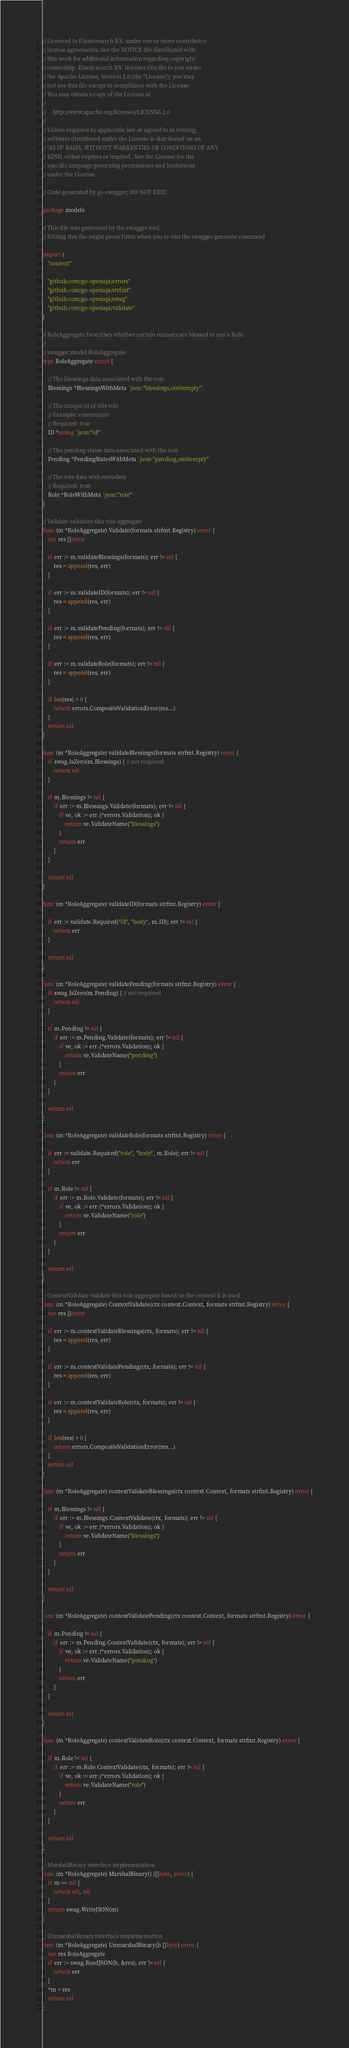<code> <loc_0><loc_0><loc_500><loc_500><_Go_>// Licensed to Elasticsearch B.V. under one or more contributor
// license agreements. See the NOTICE file distributed with
// this work for additional information regarding copyright
// ownership. Elasticsearch B.V. licenses this file to you under
// the Apache License, Version 2.0 (the "License"); you may
// not use this file except in compliance with the License.
// You may obtain a copy of the License at
//
//     http://www.apache.org/licenses/LICENSE-2.0
//
// Unless required by applicable law or agreed to in writing,
// software distributed under the License is distributed on an
// "AS IS" BASIS, WITHOUT WARRANTIES OR CONDITIONS OF ANY
// KIND, either express or implied.  See the License for the
// specific language governing permissions and limitations
// under the License.

// Code generated by go-swagger; DO NOT EDIT.

package models

// This file was generated by the swagger tool.
// Editing this file might prove futile when you re-run the swagger generate command

import (
	"context"

	"github.com/go-openapi/errors"
	"github.com/go-openapi/strfmt"
	"github.com/go-openapi/swag"
	"github.com/go-openapi/validate"
)

// RoleAggregate Describes whether certain runners are blessed to run a Role.
//
// swagger:model RoleAggregate
type RoleAggregate struct {

	// The blessings data associated with the role
	Blessings *BlessingsWithMeta `json:"blessings,omitempty"`

	// The unique id of this role
	// Example: constructor
	// Required: true
	ID *string `json:"id"`

	// The pending states data associated with the role
	Pending *PendingStatesWithMeta `json:"pending,omitempty"`

	// The role data with metadata
	// Required: true
	Role *RoleWithMeta `json:"role"`
}

// Validate validates this role aggregate
func (m *RoleAggregate) Validate(formats strfmt.Registry) error {
	var res []error

	if err := m.validateBlessings(formats); err != nil {
		res = append(res, err)
	}

	if err := m.validateID(formats); err != nil {
		res = append(res, err)
	}

	if err := m.validatePending(formats); err != nil {
		res = append(res, err)
	}

	if err := m.validateRole(formats); err != nil {
		res = append(res, err)
	}

	if len(res) > 0 {
		return errors.CompositeValidationError(res...)
	}
	return nil
}

func (m *RoleAggregate) validateBlessings(formats strfmt.Registry) error {
	if swag.IsZero(m.Blessings) { // not required
		return nil
	}

	if m.Blessings != nil {
		if err := m.Blessings.Validate(formats); err != nil {
			if ve, ok := err.(*errors.Validation); ok {
				return ve.ValidateName("blessings")
			}
			return err
		}
	}

	return nil
}

func (m *RoleAggregate) validateID(formats strfmt.Registry) error {

	if err := validate.Required("id", "body", m.ID); err != nil {
		return err
	}

	return nil
}

func (m *RoleAggregate) validatePending(formats strfmt.Registry) error {
	if swag.IsZero(m.Pending) { // not required
		return nil
	}

	if m.Pending != nil {
		if err := m.Pending.Validate(formats); err != nil {
			if ve, ok := err.(*errors.Validation); ok {
				return ve.ValidateName("pending")
			}
			return err
		}
	}

	return nil
}

func (m *RoleAggregate) validateRole(formats strfmt.Registry) error {

	if err := validate.Required("role", "body", m.Role); err != nil {
		return err
	}

	if m.Role != nil {
		if err := m.Role.Validate(formats); err != nil {
			if ve, ok := err.(*errors.Validation); ok {
				return ve.ValidateName("role")
			}
			return err
		}
	}

	return nil
}

// ContextValidate validate this role aggregate based on the context it is used
func (m *RoleAggregate) ContextValidate(ctx context.Context, formats strfmt.Registry) error {
	var res []error

	if err := m.contextValidateBlessings(ctx, formats); err != nil {
		res = append(res, err)
	}

	if err := m.contextValidatePending(ctx, formats); err != nil {
		res = append(res, err)
	}

	if err := m.contextValidateRole(ctx, formats); err != nil {
		res = append(res, err)
	}

	if len(res) > 0 {
		return errors.CompositeValidationError(res...)
	}
	return nil
}

func (m *RoleAggregate) contextValidateBlessings(ctx context.Context, formats strfmt.Registry) error {

	if m.Blessings != nil {
		if err := m.Blessings.ContextValidate(ctx, formats); err != nil {
			if ve, ok := err.(*errors.Validation); ok {
				return ve.ValidateName("blessings")
			}
			return err
		}
	}

	return nil
}

func (m *RoleAggregate) contextValidatePending(ctx context.Context, formats strfmt.Registry) error {

	if m.Pending != nil {
		if err := m.Pending.ContextValidate(ctx, formats); err != nil {
			if ve, ok := err.(*errors.Validation); ok {
				return ve.ValidateName("pending")
			}
			return err
		}
	}

	return nil
}

func (m *RoleAggregate) contextValidateRole(ctx context.Context, formats strfmt.Registry) error {

	if m.Role != nil {
		if err := m.Role.ContextValidate(ctx, formats); err != nil {
			if ve, ok := err.(*errors.Validation); ok {
				return ve.ValidateName("role")
			}
			return err
		}
	}

	return nil
}

// MarshalBinary interface implementation
func (m *RoleAggregate) MarshalBinary() ([]byte, error) {
	if m == nil {
		return nil, nil
	}
	return swag.WriteJSON(m)
}

// UnmarshalBinary interface implementation
func (m *RoleAggregate) UnmarshalBinary(b []byte) error {
	var res RoleAggregate
	if err := swag.ReadJSON(b, &res); err != nil {
		return err
	}
	*m = res
	return nil
}
</code> 